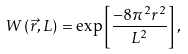<formula> <loc_0><loc_0><loc_500><loc_500>W \left ( \vec { r } , L \right ) = \exp \left [ \frac { - 8 \pi ^ { 2 } r ^ { 2 } } { L ^ { 2 } } \right ] ,</formula> 